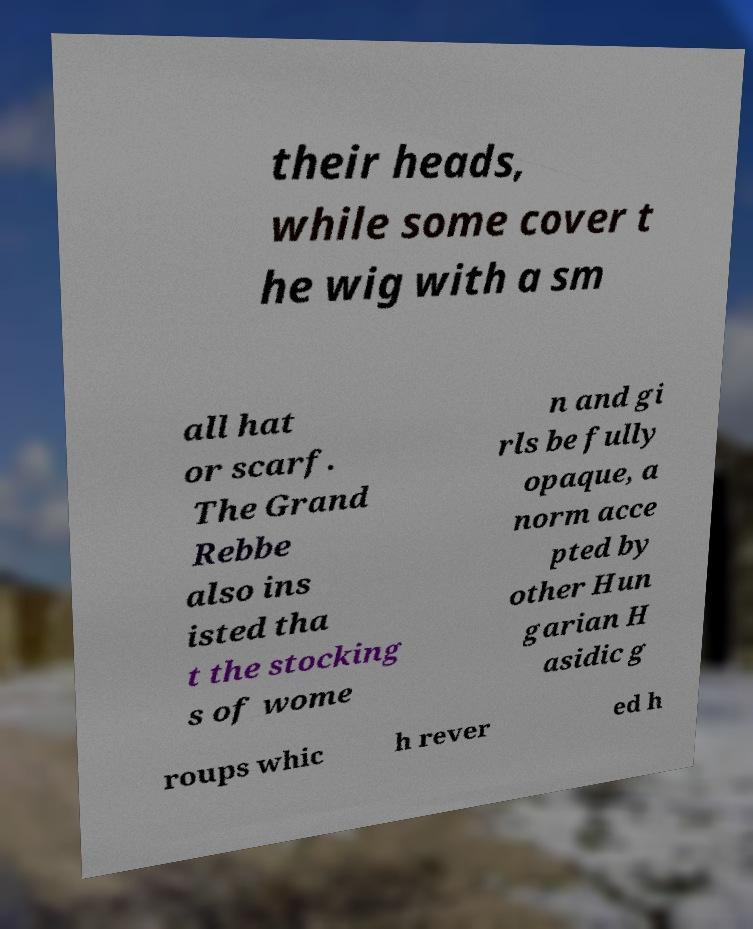Please identify and transcribe the text found in this image. their heads, while some cover t he wig with a sm all hat or scarf. The Grand Rebbe also ins isted tha t the stocking s of wome n and gi rls be fully opaque, a norm acce pted by other Hun garian H asidic g roups whic h rever ed h 